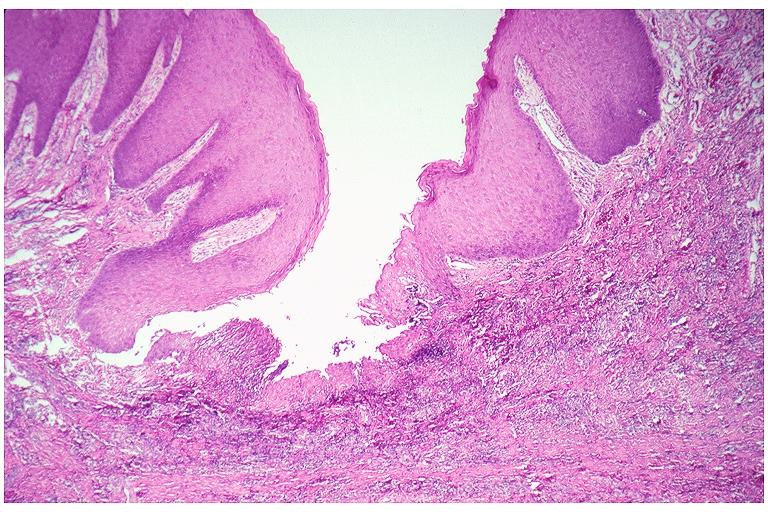does this image show epulis fissuratum?
Answer the question using a single word or phrase. Yes 